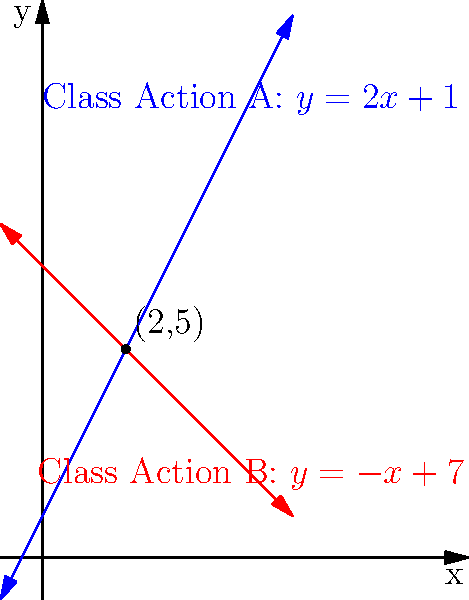In a complex product recall case, two competing class action lawsuits have been filed. The potential settlement amounts for these lawsuits can be represented by two linear equations:

Class Action A: $y = 2x + 1$
Class Action B: $y = -x + 7$

Where $x$ represents the number of affected consumers (in millions) and $y$ represents the potential settlement amount (in millions of dollars).

At what point do these two class action claims intersect, and what does this intersection represent in the context of the case? To find the intersection point of the two lines, we need to solve the system of equations:

1) $y = 2x + 1$ (Class Action A)
2) $y = -x + 7$ (Class Action B)

At the intersection point, the $y$ values are equal, so we can set the right sides of the equations equal to each other:

3) $2x + 1 = -x + 7$

Now, let's solve for $x$:

4) $2x + x = 7 - 1$
5) $3x = 6$
6) $x = 2$

To find the $y$ coordinate, we can substitute $x = 2$ into either of the original equations. Let's use Class Action A:

7) $y = 2(2) + 1 = 4 + 1 = 5$

Therefore, the intersection point is $(2, 5)$.

In the context of the case, this intersection represents:

- Number of affected consumers: 2 million
- Potential settlement amount: $5 million

This point indicates that when the number of affected consumers reaches 2 million, both class action lawsuits would result in the same settlement amount of $5 million. For any number of consumers less than 2 million, Class Action B would result in a higher settlement, while for any number greater than 2 million, Class Action A would yield a higher settlement.
Answer: (2, 5); representing 2 million affected consumers and a $5 million settlement where both class actions yield equal results. 